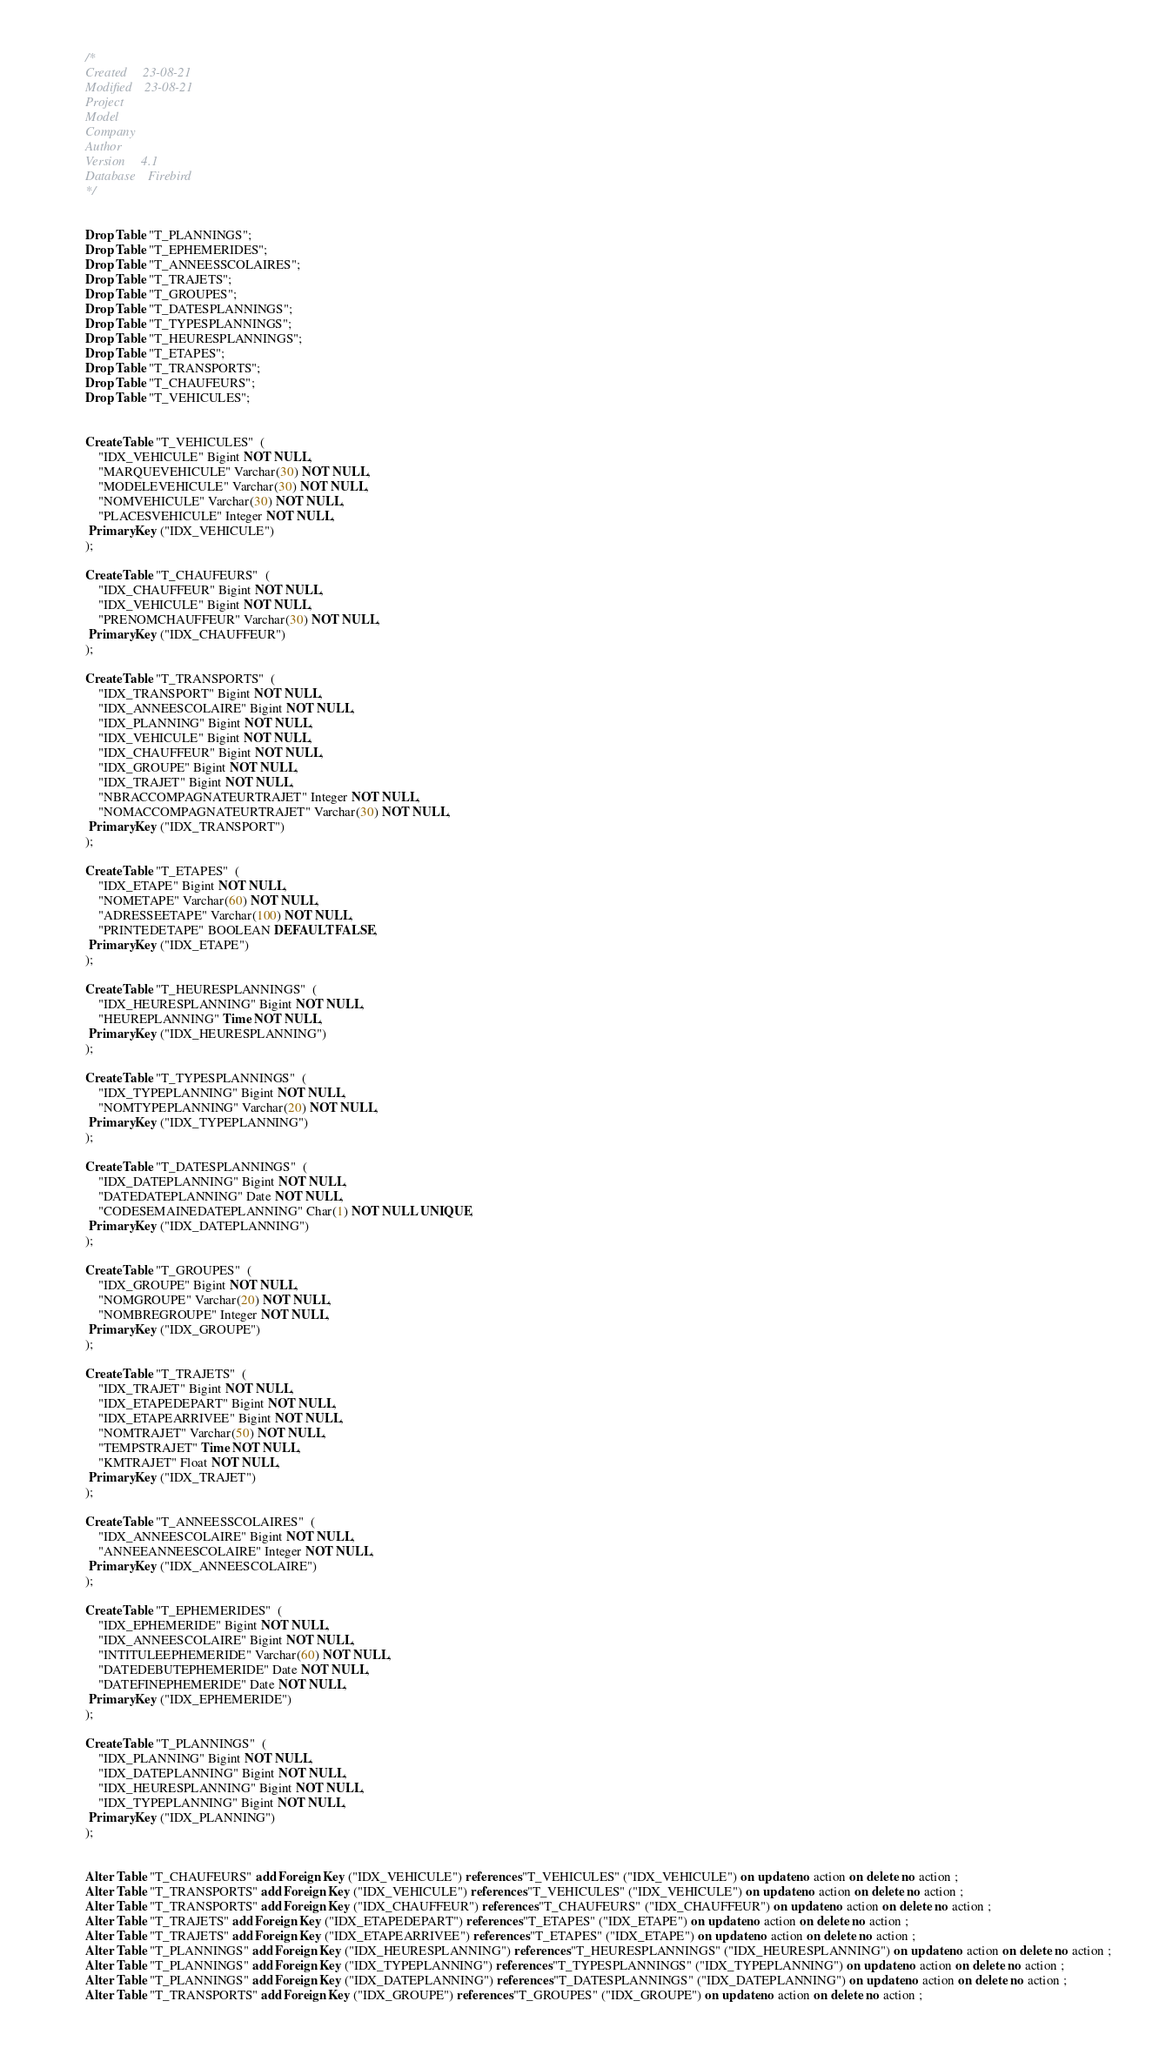Convert code to text. <code><loc_0><loc_0><loc_500><loc_500><_SQL_>/*
Created		23-08-21
Modified	23-08-21
Project		
Model		
Company		
Author		
Version		4.1
Database	Firebird 
*/


Drop Table "T_PLANNINGS";
Drop Table "T_EPHEMERIDES";
Drop Table "T_ANNEESSCOLAIRES";
Drop Table "T_TRAJETS";
Drop Table "T_GROUPES";
Drop Table "T_DATESPLANNINGS";
Drop Table "T_TYPESPLANNINGS";
Drop Table "T_HEURESPLANNINGS";
Drop Table "T_ETAPES";
Drop Table "T_TRANSPORTS";
Drop Table "T_CHAUFEURS";
Drop Table "T_VEHICULES";


Create Table "T_VEHICULES"  (
	"IDX_VEHICULE" Bigint NOT NULL,
	"MARQUEVEHICULE" Varchar(30) NOT NULL,
	"MODELEVEHICULE" Varchar(30) NOT NULL,
	"NOMVEHICULE" Varchar(30) NOT NULL,
	"PLACESVEHICULE" Integer NOT NULL,
 Primary Key ("IDX_VEHICULE")
);

Create Table "T_CHAUFEURS"  (
	"IDX_CHAUFFEUR" Bigint NOT NULL,
	"IDX_VEHICULE" Bigint NOT NULL,
	"PRENOMCHAUFFEUR" Varchar(30) NOT NULL,
 Primary Key ("IDX_CHAUFFEUR")
);

Create Table "T_TRANSPORTS"  (
	"IDX_TRANSPORT" Bigint NOT NULL,
	"IDX_ANNEESCOLAIRE" Bigint NOT NULL,
	"IDX_PLANNING" Bigint NOT NULL,
	"IDX_VEHICULE" Bigint NOT NULL,
	"IDX_CHAUFFEUR" Bigint NOT NULL,
	"IDX_GROUPE" Bigint NOT NULL,
	"IDX_TRAJET" Bigint NOT NULL,
	"NBRACCOMPAGNATEURTRAJET" Integer NOT NULL,
	"NOMACCOMPAGNATEURTRAJET" Varchar(30) NOT NULL,
 Primary Key ("IDX_TRANSPORT")
);

Create Table "T_ETAPES"  (
	"IDX_ETAPE" Bigint NOT NULL,
	"NOMETAPE" Varchar(60) NOT NULL,
	"ADRESSEETAPE" Varchar(100) NOT NULL,
	"PRINTEDETAPE" BOOLEAN DEFAULT FALSE,
 Primary Key ("IDX_ETAPE")
);

Create Table "T_HEURESPLANNINGS"  (
	"IDX_HEURESPLANNING" Bigint NOT NULL,
	"HEUREPLANNING" Time NOT NULL,
 Primary Key ("IDX_HEURESPLANNING")
);

Create Table "T_TYPESPLANNINGS"  (
	"IDX_TYPEPLANNING" Bigint NOT NULL,
	"NOMTYPEPLANNING" Varchar(20) NOT NULL,
 Primary Key ("IDX_TYPEPLANNING")
);

Create Table "T_DATESPLANNINGS"  (
	"IDX_DATEPLANNING" Bigint NOT NULL,
	"DATEDATEPLANNING" Date NOT NULL,
	"CODESEMAINEDATEPLANNING" Char(1) NOT NULL UNIQUE,
 Primary Key ("IDX_DATEPLANNING")
);

Create Table "T_GROUPES"  (
	"IDX_GROUPE" Bigint NOT NULL,
	"NOMGROUPE" Varchar(20) NOT NULL,
	"NOMBREGROUPE" Integer NOT NULL,
 Primary Key ("IDX_GROUPE")
);

Create Table "T_TRAJETS"  (
	"IDX_TRAJET" Bigint NOT NULL,
	"IDX_ETAPEDEPART" Bigint NOT NULL,
	"IDX_ETAPEARRIVEE" Bigint NOT NULL,
	"NOMTRAJET" Varchar(50) NOT NULL,
	"TEMPSTRAJET" Time NOT NULL,
	"KMTRAJET" Float NOT NULL,
 Primary Key ("IDX_TRAJET")
);

Create Table "T_ANNEESSCOLAIRES"  (
	"IDX_ANNEESCOLAIRE" Bigint NOT NULL,
	"ANNEEANNEESCOLAIRE" Integer NOT NULL,
 Primary Key ("IDX_ANNEESCOLAIRE")
);

Create Table "T_EPHEMERIDES"  (
	"IDX_EPHEMERIDE" Bigint NOT NULL,
	"IDX_ANNEESCOLAIRE" Bigint NOT NULL,
	"INTITULEEPHEMERIDE" Varchar(60) NOT NULL,
	"DATEDEBUTEPHEMERIDE" Date NOT NULL,
	"DATEFINEPHEMERIDE" Date NOT NULL,
 Primary Key ("IDX_EPHEMERIDE")
);

Create Table "T_PLANNINGS"  (
	"IDX_PLANNING" Bigint NOT NULL,
	"IDX_DATEPLANNING" Bigint NOT NULL,
	"IDX_HEURESPLANNING" Bigint NOT NULL,
	"IDX_TYPEPLANNING" Bigint NOT NULL,
 Primary Key ("IDX_PLANNING")
);


Alter Table "T_CHAUFEURS" add Foreign Key ("IDX_VEHICULE") references "T_VEHICULES" ("IDX_VEHICULE") on update no action on delete no action ;
Alter Table "T_TRANSPORTS" add Foreign Key ("IDX_VEHICULE") references "T_VEHICULES" ("IDX_VEHICULE") on update no action on delete no action ;
Alter Table "T_TRANSPORTS" add Foreign Key ("IDX_CHAUFFEUR") references "T_CHAUFEURS" ("IDX_CHAUFFEUR") on update no action on delete no action ;
Alter Table "T_TRAJETS" add Foreign Key ("IDX_ETAPEDEPART") references "T_ETAPES" ("IDX_ETAPE") on update no action on delete no action ;
Alter Table "T_TRAJETS" add Foreign Key ("IDX_ETAPEARRIVEE") references "T_ETAPES" ("IDX_ETAPE") on update no action on delete no action ;
Alter Table "T_PLANNINGS" add Foreign Key ("IDX_HEURESPLANNING") references "T_HEURESPLANNINGS" ("IDX_HEURESPLANNING") on update no action on delete no action ;
Alter Table "T_PLANNINGS" add Foreign Key ("IDX_TYPEPLANNING") references "T_TYPESPLANNINGS" ("IDX_TYPEPLANNING") on update no action on delete no action ;
Alter Table "T_PLANNINGS" add Foreign Key ("IDX_DATEPLANNING") references "T_DATESPLANNINGS" ("IDX_DATEPLANNING") on update no action on delete no action ;
Alter Table "T_TRANSPORTS" add Foreign Key ("IDX_GROUPE") references "T_GROUPES" ("IDX_GROUPE") on update no action on delete no action ;</code> 